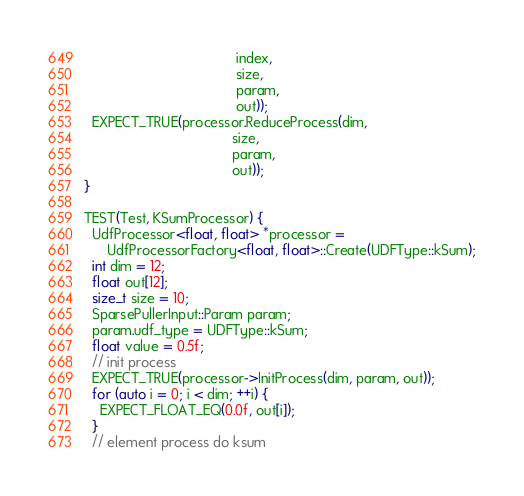Convert code to text. <code><loc_0><loc_0><loc_500><loc_500><_C++_>                                       index,
                                       size,
                                       param,
                                       out));
  EXPECT_TRUE(processor.ReduceProcess(dim,
                                      size,
                                      param,
                                      out));
}

TEST(Test, KSumProcessor) {
  UdfProcessor<float, float> *processor =
      UdfProcessorFactory<float, float>::Create(UDFType::kSum);
  int dim = 12;
  float out[12];
  size_t size = 10;
  SparsePullerInput::Param param;
  param.udf_type = UDFType::kSum;
  float value = 0.5f;
  // init process
  EXPECT_TRUE(processor->InitProcess(dim, param, out));
  for (auto i = 0; i < dim; ++i) {
    EXPECT_FLOAT_EQ(0.0f, out[i]);
  }
  // element process do ksum</code> 